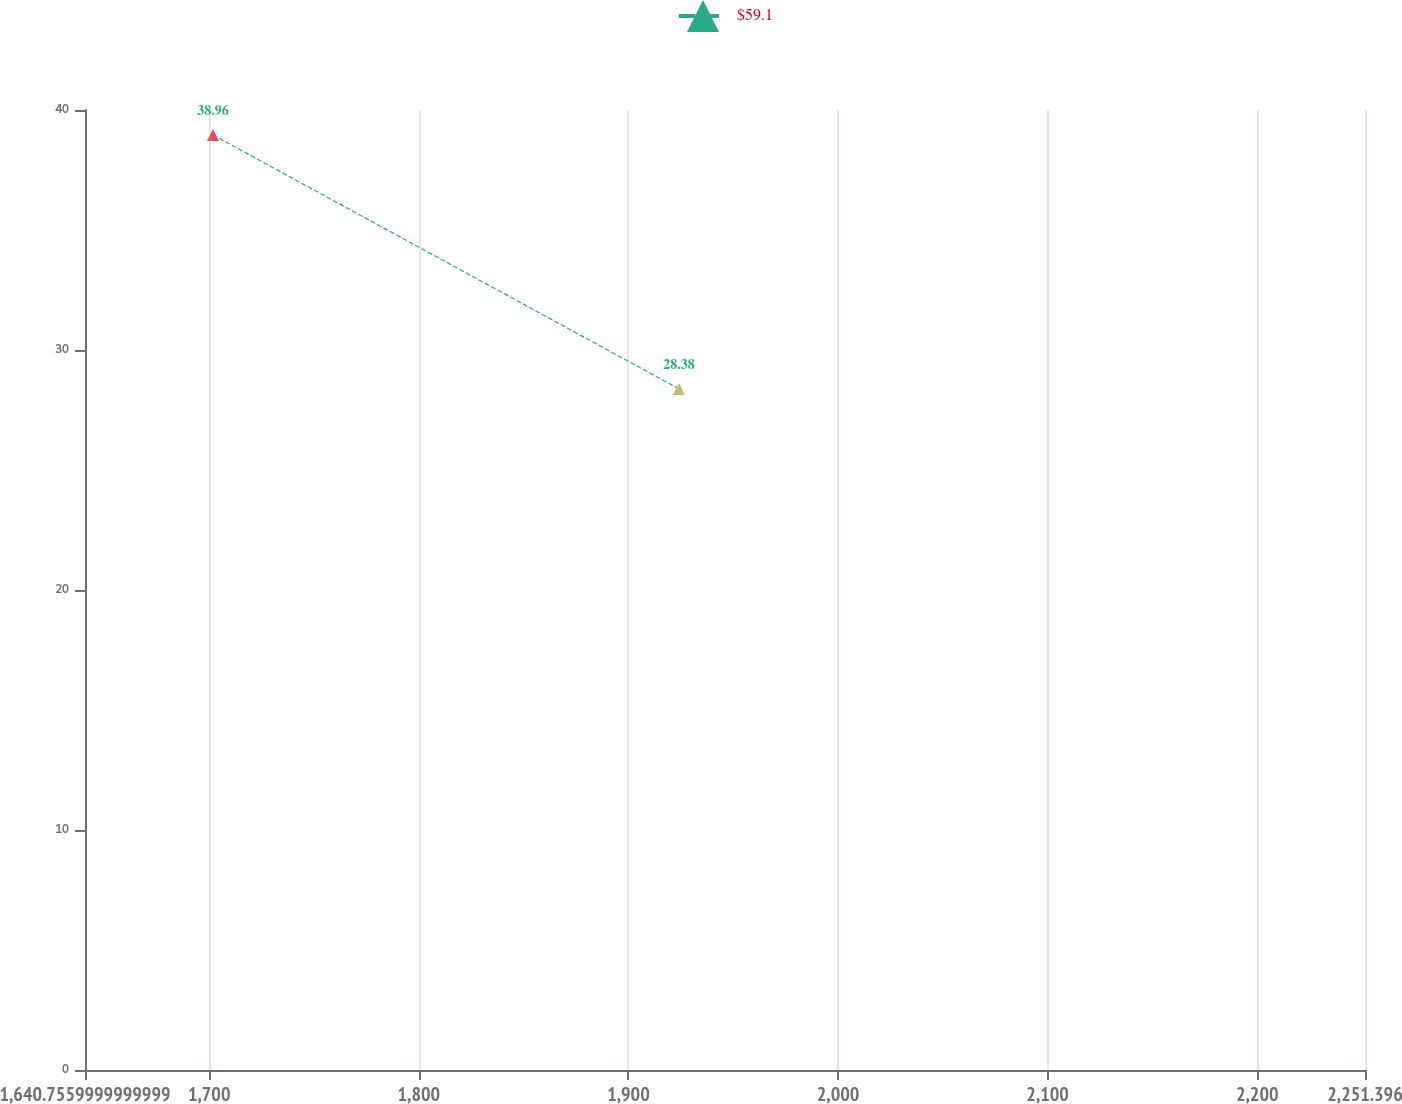Convert chart. <chart><loc_0><loc_0><loc_500><loc_500><line_chart><ecel><fcel>$59.1<nl><fcel>1701.82<fcel>38.96<nl><fcel>1924.1<fcel>28.38<nl><fcel>2254.25<fcel>26.72<nl><fcel>2312.46<fcel>22.31<nl></chart> 